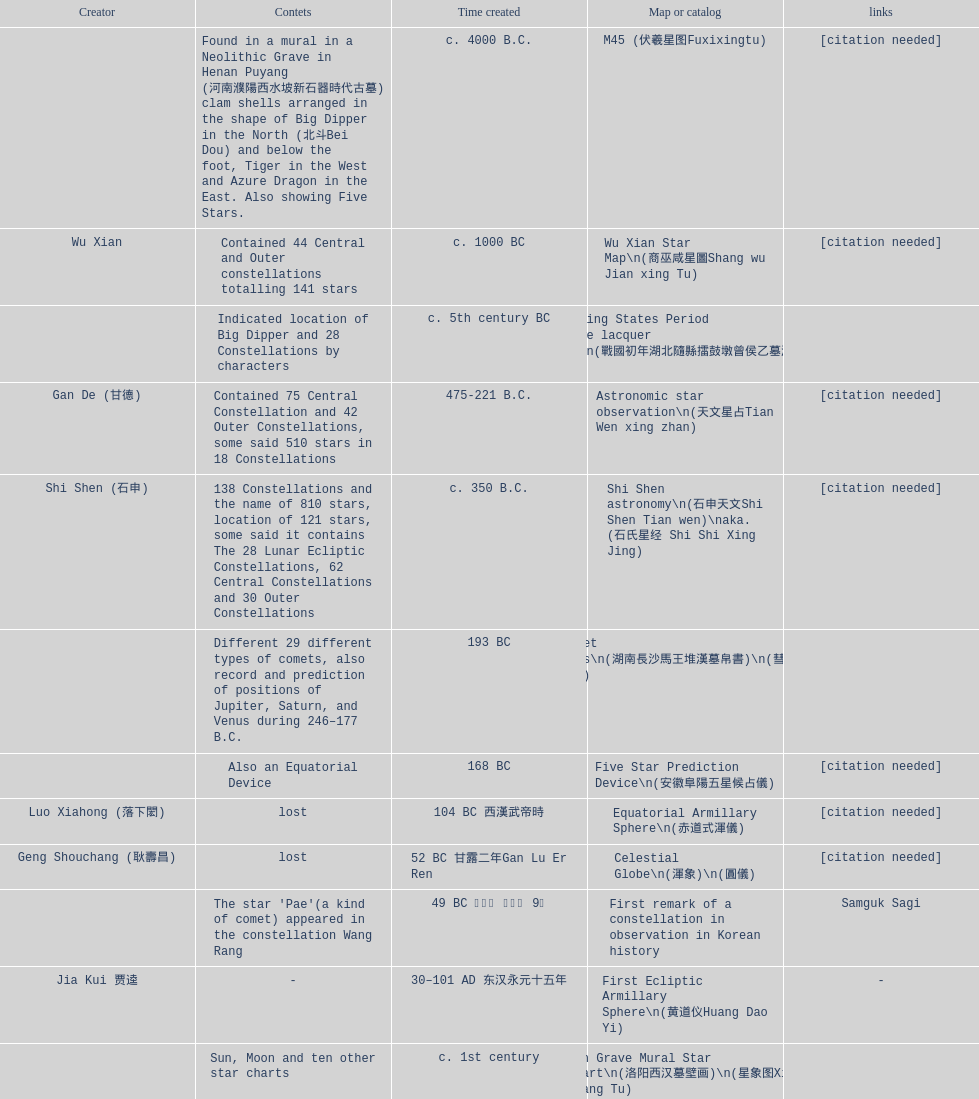What is the discrepancy between the five star prediction device's creation date and the han comet diagrams' creation date? 25 years. 